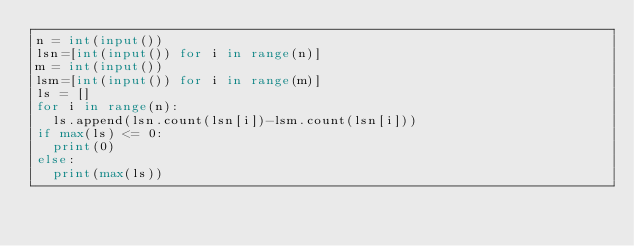Convert code to text. <code><loc_0><loc_0><loc_500><loc_500><_Python_>n = int(input())
lsn=[int(input()) for i in range(n)]
m = int(input())
lsm=[int(input()) for i in range(m)]
ls = []
for i in range(n):
  ls.append(lsn.count(lsn[i])-lsm.count(lsn[i]))
if max(ls) <= 0:
  print(0)
else:
  print(max(ls))</code> 